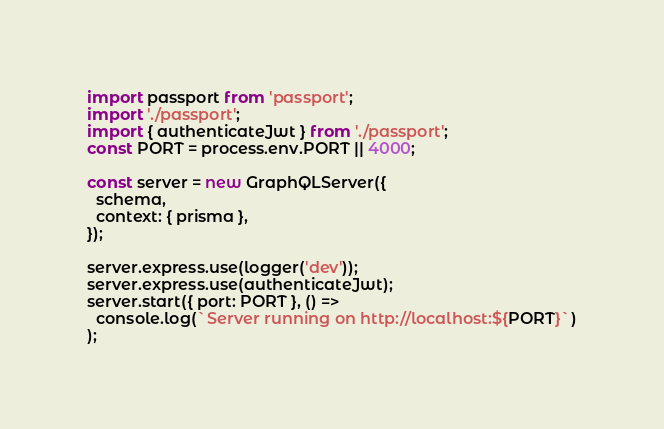Convert code to text. <code><loc_0><loc_0><loc_500><loc_500><_JavaScript_>import passport from 'passport';
import './passport';
import { authenticateJwt } from './passport';
const PORT = process.env.PORT || 4000;

const server = new GraphQLServer({
  schema,
  context: { prisma },
});

server.express.use(logger('dev'));
server.express.use(authenticateJwt);
server.start({ port: PORT }, () =>
  console.log(`Server running on http://localhost:${PORT}`)
);
</code> 